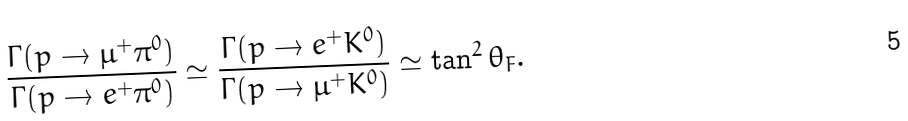<formula> <loc_0><loc_0><loc_500><loc_500>\frac { \Gamma ( p \rightarrow \mu ^ { + } \pi ^ { 0 } ) } { \Gamma ( p \rightarrow e ^ { + } \pi ^ { 0 } ) } \simeq \frac { \Gamma ( p \rightarrow e ^ { + } K ^ { 0 } ) } { \Gamma ( p \rightarrow \mu ^ { + } K ^ { 0 } ) } \simeq \tan ^ { 2 } \theta _ { F } .</formula> 